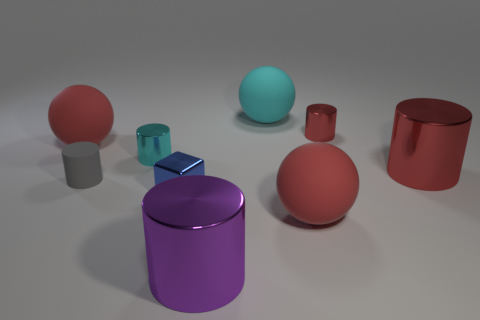Subtract all large red matte spheres. How many spheres are left? 1 Subtract all cyan cylinders. How many red spheres are left? 2 Subtract all gray cylinders. How many cylinders are left? 4 Subtract all gray spheres. Subtract all brown blocks. How many spheres are left? 3 Subtract all balls. How many objects are left? 6 Add 1 blue cubes. How many blue cubes are left? 2 Add 4 cyan things. How many cyan things exist? 6 Subtract 1 cyan cylinders. How many objects are left? 8 Subtract all shiny cubes. Subtract all blue cubes. How many objects are left? 7 